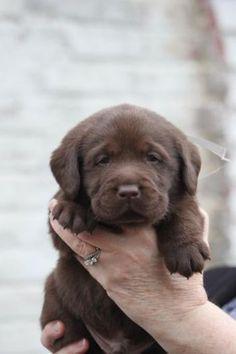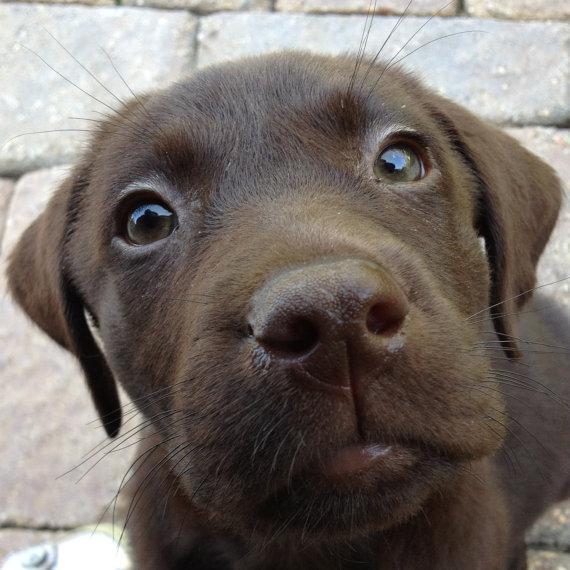The first image is the image on the left, the second image is the image on the right. Evaluate the accuracy of this statement regarding the images: "One image features at least three dogs posed in a row.". Is it true? Answer yes or no. No. The first image is the image on the left, the second image is the image on the right. Examine the images to the left and right. Is the description "There are no fewer than three dogs in one of the images." accurate? Answer yes or no. No. 